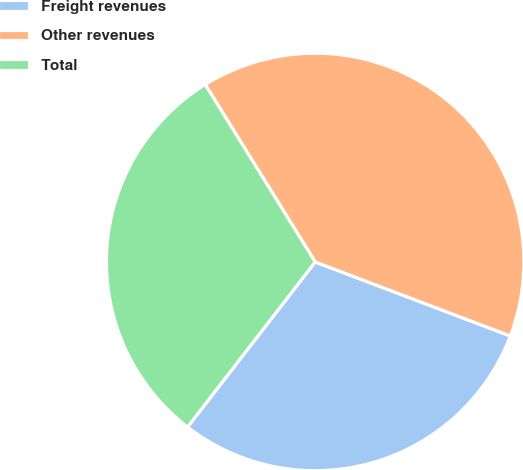Convert chart. <chart><loc_0><loc_0><loc_500><loc_500><pie_chart><fcel>Freight revenues<fcel>Other revenues<fcel>Total<nl><fcel>29.7%<fcel>39.6%<fcel>30.69%<nl></chart> 